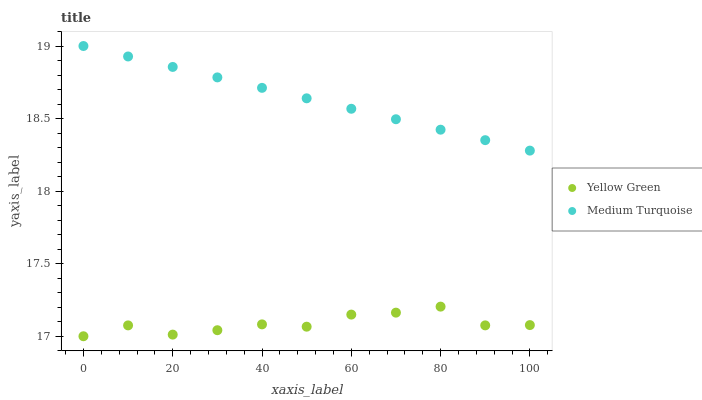Does Yellow Green have the minimum area under the curve?
Answer yes or no. Yes. Does Medium Turquoise have the maximum area under the curve?
Answer yes or no. Yes. Does Medium Turquoise have the minimum area under the curve?
Answer yes or no. No. Is Medium Turquoise the smoothest?
Answer yes or no. Yes. Is Yellow Green the roughest?
Answer yes or no. Yes. Is Medium Turquoise the roughest?
Answer yes or no. No. Does Yellow Green have the lowest value?
Answer yes or no. Yes. Does Medium Turquoise have the lowest value?
Answer yes or no. No. Does Medium Turquoise have the highest value?
Answer yes or no. Yes. Is Yellow Green less than Medium Turquoise?
Answer yes or no. Yes. Is Medium Turquoise greater than Yellow Green?
Answer yes or no. Yes. Does Yellow Green intersect Medium Turquoise?
Answer yes or no. No. 